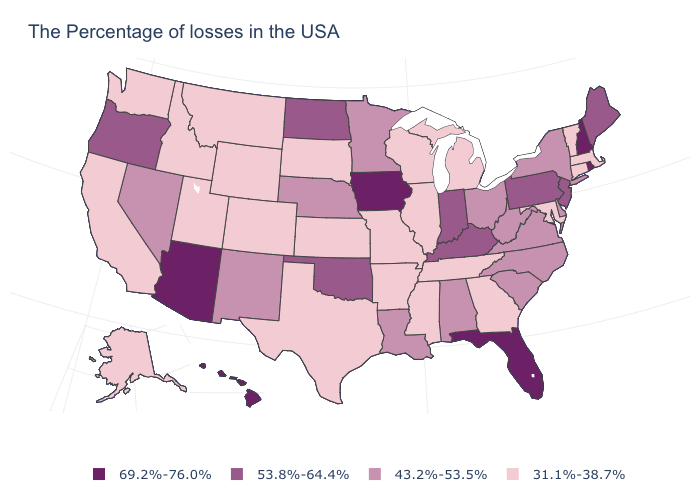Does West Virginia have the lowest value in the USA?
Give a very brief answer. No. What is the value of Maine?
Quick response, please. 53.8%-64.4%. What is the highest value in the USA?
Quick response, please. 69.2%-76.0%. What is the value of Michigan?
Short answer required. 31.1%-38.7%. Which states have the highest value in the USA?
Be succinct. Rhode Island, New Hampshire, Florida, Iowa, Arizona, Hawaii. What is the value of Idaho?
Concise answer only. 31.1%-38.7%. Is the legend a continuous bar?
Concise answer only. No. Does Iowa have the highest value in the MidWest?
Answer briefly. Yes. What is the lowest value in states that border Louisiana?
Short answer required. 31.1%-38.7%. What is the highest value in the USA?
Answer briefly. 69.2%-76.0%. Which states hav the highest value in the Northeast?
Concise answer only. Rhode Island, New Hampshire. Does New Mexico have a higher value than Arkansas?
Write a very short answer. Yes. Name the states that have a value in the range 69.2%-76.0%?
Answer briefly. Rhode Island, New Hampshire, Florida, Iowa, Arizona, Hawaii. Name the states that have a value in the range 53.8%-64.4%?
Give a very brief answer. Maine, New Jersey, Pennsylvania, Kentucky, Indiana, Oklahoma, North Dakota, Oregon. Which states have the lowest value in the USA?
Short answer required. Massachusetts, Vermont, Connecticut, Maryland, Georgia, Michigan, Tennessee, Wisconsin, Illinois, Mississippi, Missouri, Arkansas, Kansas, Texas, South Dakota, Wyoming, Colorado, Utah, Montana, Idaho, California, Washington, Alaska. 